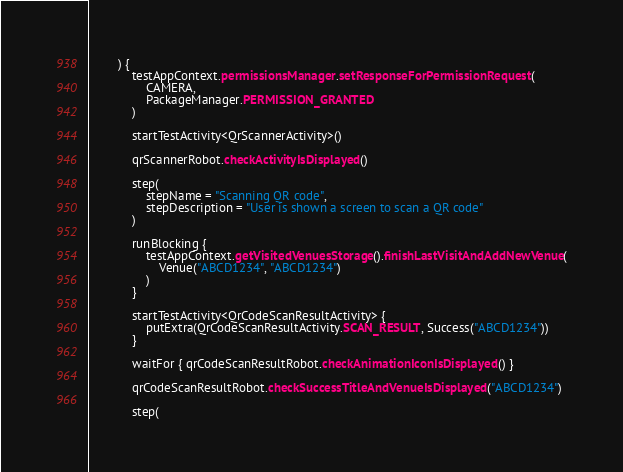Convert code to text. <code><loc_0><loc_0><loc_500><loc_500><_Kotlin_>        ) {
            testAppContext.permissionsManager.setResponseForPermissionRequest(
                CAMERA,
                PackageManager.PERMISSION_GRANTED
            )

            startTestActivity<QrScannerActivity>()

            qrScannerRobot.checkActivityIsDisplayed()

            step(
                stepName = "Scanning QR code",
                stepDescription = "User is shown a screen to scan a QR code"
            )

            runBlocking {
                testAppContext.getVisitedVenuesStorage().finishLastVisitAndAddNewVenue(
                    Venue("ABCD1234", "ABCD1234")
                )
            }

            startTestActivity<QrCodeScanResultActivity> {
                putExtra(QrCodeScanResultActivity.SCAN_RESULT, Success("ABCD1234"))
            }

            waitFor { qrCodeScanResultRobot.checkAnimationIconIsDisplayed() }

            qrCodeScanResultRobot.checkSuccessTitleAndVenueIsDisplayed("ABCD1234")

            step(</code> 